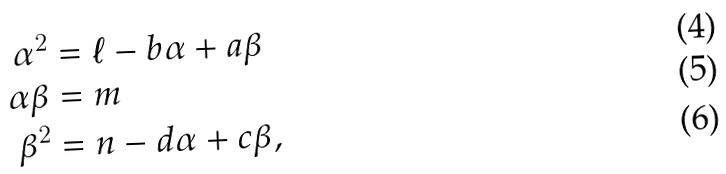<formula> <loc_0><loc_0><loc_500><loc_500>\alpha ^ { 2 } & = \ell - b \alpha + a \beta \\ \alpha \beta & = m \\ \beta ^ { 2 } & = n - d \alpha + c \beta ,</formula> 